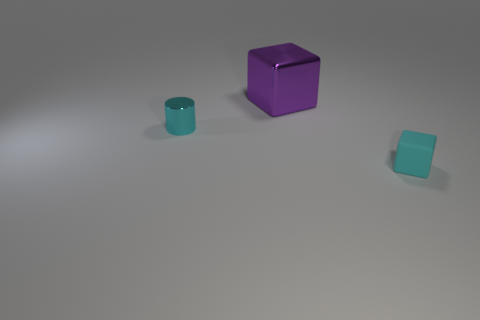Add 3 big purple things. How many objects exist? 6 Subtract all blocks. How many objects are left? 1 Subtract all cyan objects. Subtract all small cyan blocks. How many objects are left? 0 Add 2 purple objects. How many purple objects are left? 3 Add 2 cyan metallic cylinders. How many cyan metallic cylinders exist? 3 Subtract 0 gray blocks. How many objects are left? 3 